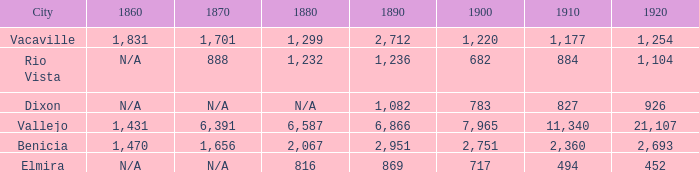What is the 1920 number when 1890 is greater than 1,236, 1910 is less than 1,177 and the city is Vacaville? None. 